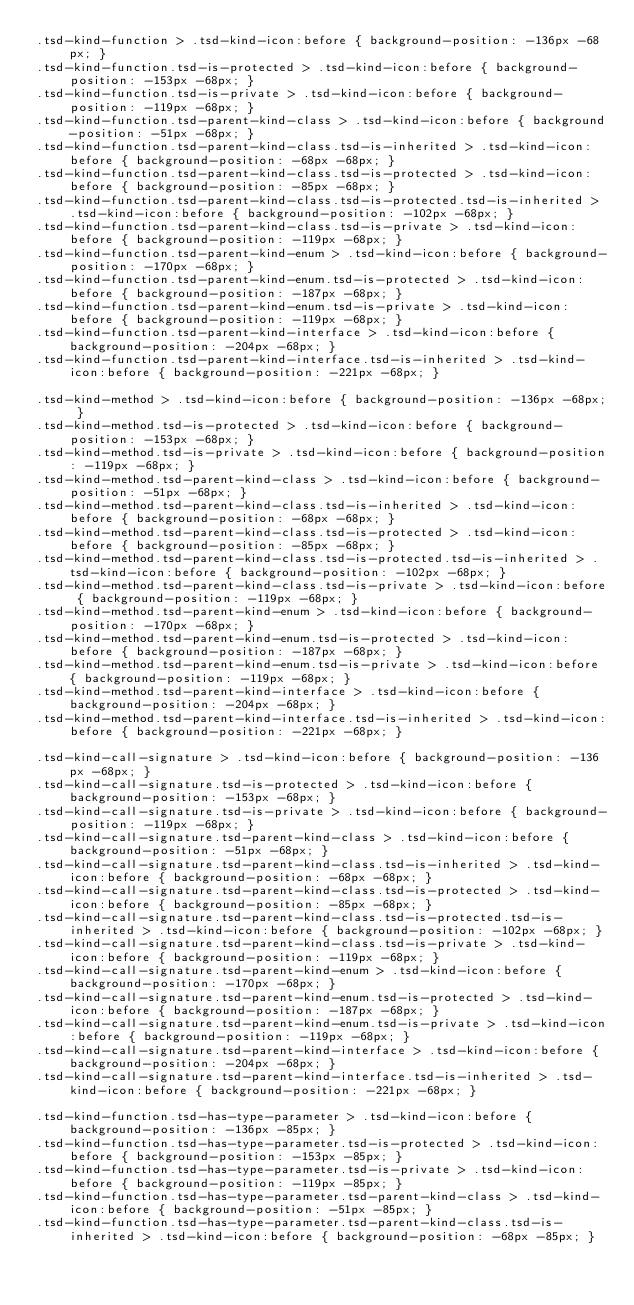<code> <loc_0><loc_0><loc_500><loc_500><_HTML_>.tsd-kind-function > .tsd-kind-icon:before { background-position: -136px -68px; }
.tsd-kind-function.tsd-is-protected > .tsd-kind-icon:before { background-position: -153px -68px; }
.tsd-kind-function.tsd-is-private > .tsd-kind-icon:before { background-position: -119px -68px; }
.tsd-kind-function.tsd-parent-kind-class > .tsd-kind-icon:before { background-position: -51px -68px; }
.tsd-kind-function.tsd-parent-kind-class.tsd-is-inherited > .tsd-kind-icon:before { background-position: -68px -68px; }
.tsd-kind-function.tsd-parent-kind-class.tsd-is-protected > .tsd-kind-icon:before { background-position: -85px -68px; }
.tsd-kind-function.tsd-parent-kind-class.tsd-is-protected.tsd-is-inherited > .tsd-kind-icon:before { background-position: -102px -68px; }
.tsd-kind-function.tsd-parent-kind-class.tsd-is-private > .tsd-kind-icon:before { background-position: -119px -68px; }
.tsd-kind-function.tsd-parent-kind-enum > .tsd-kind-icon:before { background-position: -170px -68px; }
.tsd-kind-function.tsd-parent-kind-enum.tsd-is-protected > .tsd-kind-icon:before { background-position: -187px -68px; }
.tsd-kind-function.tsd-parent-kind-enum.tsd-is-private > .tsd-kind-icon:before { background-position: -119px -68px; }
.tsd-kind-function.tsd-parent-kind-interface > .tsd-kind-icon:before { background-position: -204px -68px; }
.tsd-kind-function.tsd-parent-kind-interface.tsd-is-inherited > .tsd-kind-icon:before { background-position: -221px -68px; }

.tsd-kind-method > .tsd-kind-icon:before { background-position: -136px -68px; }
.tsd-kind-method.tsd-is-protected > .tsd-kind-icon:before { background-position: -153px -68px; }
.tsd-kind-method.tsd-is-private > .tsd-kind-icon:before { background-position: -119px -68px; }
.tsd-kind-method.tsd-parent-kind-class > .tsd-kind-icon:before { background-position: -51px -68px; }
.tsd-kind-method.tsd-parent-kind-class.tsd-is-inherited > .tsd-kind-icon:before { background-position: -68px -68px; }
.tsd-kind-method.tsd-parent-kind-class.tsd-is-protected > .tsd-kind-icon:before { background-position: -85px -68px; }
.tsd-kind-method.tsd-parent-kind-class.tsd-is-protected.tsd-is-inherited > .tsd-kind-icon:before { background-position: -102px -68px; }
.tsd-kind-method.tsd-parent-kind-class.tsd-is-private > .tsd-kind-icon:before { background-position: -119px -68px; }
.tsd-kind-method.tsd-parent-kind-enum > .tsd-kind-icon:before { background-position: -170px -68px; }
.tsd-kind-method.tsd-parent-kind-enum.tsd-is-protected > .tsd-kind-icon:before { background-position: -187px -68px; }
.tsd-kind-method.tsd-parent-kind-enum.tsd-is-private > .tsd-kind-icon:before { background-position: -119px -68px; }
.tsd-kind-method.tsd-parent-kind-interface > .tsd-kind-icon:before { background-position: -204px -68px; }
.tsd-kind-method.tsd-parent-kind-interface.tsd-is-inherited > .tsd-kind-icon:before { background-position: -221px -68px; }

.tsd-kind-call-signature > .tsd-kind-icon:before { background-position: -136px -68px; }
.tsd-kind-call-signature.tsd-is-protected > .tsd-kind-icon:before { background-position: -153px -68px; }
.tsd-kind-call-signature.tsd-is-private > .tsd-kind-icon:before { background-position: -119px -68px; }
.tsd-kind-call-signature.tsd-parent-kind-class > .tsd-kind-icon:before { background-position: -51px -68px; }
.tsd-kind-call-signature.tsd-parent-kind-class.tsd-is-inherited > .tsd-kind-icon:before { background-position: -68px -68px; }
.tsd-kind-call-signature.tsd-parent-kind-class.tsd-is-protected > .tsd-kind-icon:before { background-position: -85px -68px; }
.tsd-kind-call-signature.tsd-parent-kind-class.tsd-is-protected.tsd-is-inherited > .tsd-kind-icon:before { background-position: -102px -68px; }
.tsd-kind-call-signature.tsd-parent-kind-class.tsd-is-private > .tsd-kind-icon:before { background-position: -119px -68px; }
.tsd-kind-call-signature.tsd-parent-kind-enum > .tsd-kind-icon:before { background-position: -170px -68px; }
.tsd-kind-call-signature.tsd-parent-kind-enum.tsd-is-protected > .tsd-kind-icon:before { background-position: -187px -68px; }
.tsd-kind-call-signature.tsd-parent-kind-enum.tsd-is-private > .tsd-kind-icon:before { background-position: -119px -68px; }
.tsd-kind-call-signature.tsd-parent-kind-interface > .tsd-kind-icon:before { background-position: -204px -68px; }
.tsd-kind-call-signature.tsd-parent-kind-interface.tsd-is-inherited > .tsd-kind-icon:before { background-position: -221px -68px; }

.tsd-kind-function.tsd-has-type-parameter > .tsd-kind-icon:before { background-position: -136px -85px; }
.tsd-kind-function.tsd-has-type-parameter.tsd-is-protected > .tsd-kind-icon:before { background-position: -153px -85px; }
.tsd-kind-function.tsd-has-type-parameter.tsd-is-private > .tsd-kind-icon:before { background-position: -119px -85px; }
.tsd-kind-function.tsd-has-type-parameter.tsd-parent-kind-class > .tsd-kind-icon:before { background-position: -51px -85px; }
.tsd-kind-function.tsd-has-type-parameter.tsd-parent-kind-class.tsd-is-inherited > .tsd-kind-icon:before { background-position: -68px -85px; }</code> 